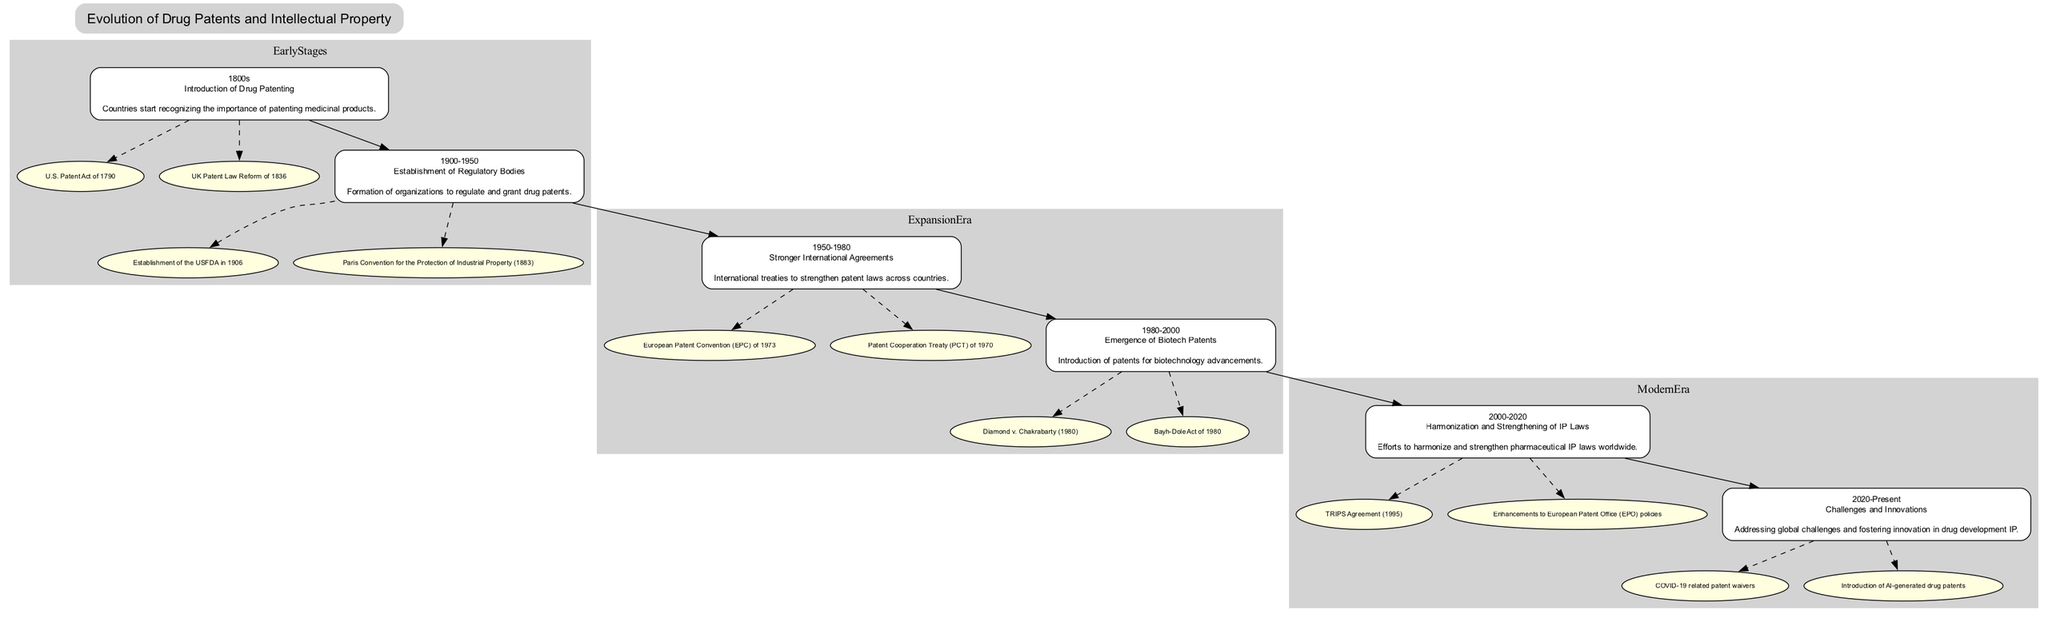What is the milestone of the period 1900-1950? The diagram indicates that the milestone for the period 1900-1950 is "Establishment of Regulatory Bodies." This is identified by looking at the specific node for that period in the "EarlyStages" era.
Answer: Establishment of Regulatory Bodies How many notable examples are listed for the 1980-2000 period? In the diagram, there are two notable examples listed under the 1980-2000 period, specifically "Diamond v. Chakrabarty (1980)" and "Bayh-Dole Act of 1980." Thus, I count these entries under the relevant node.
Answer: 2 Which era directly precedes the ModernEra? By examining the connections in the diagram, I see that the "ExpansionEra" which encompasses the periods 1950-1980 and 1980-2000 directly precedes the "ModernEra." Therefore, looking at the edges leads to this conclusion.
Answer: ExpansionEra What notable example is associated with the 2000-2020 period? The diagram specifies "TRIPS Agreement (1995)" as a notable example for the 2000-2020 period. This can be found by checking the relevant node in the "ModernEra" section.
Answer: TRIPS Agreement (1995) How many eras are represented in the family tree? The family tree diagram showcases three eras: "EarlyStages," "ExpansionEra," and "ModernEra." By counting the clusters or sections in the tree, I determine that there are a total of three different eras visible.
Answer: 3 What relationship exists between the periods 1950-1980 and 1980-2000? In the diagram, there is a direct edge connecting the periods 1950-1980 to 1980-2000, indicating that the latter follows the former chronologically within the "ExpansionEra." Thus, I assess the relationship based on their sequential arrangement.
Answer: Direct connection Which period introduced patents for biotechnology advancements? The diagram clearly states that the period 1980-2000 is the one that introduced patents for biotechnology advancements by looking at the milestone labeled under that specific time frame.
Answer: 1980-2000 What is the main focus of the ModernEra from 2020 to the present? According to the diagram, the main focus of the ModernEra from 2020 to present is "Challenges and Innovations." This information is derived from the description included in that period's node.
Answer: Challenges and Innovations 